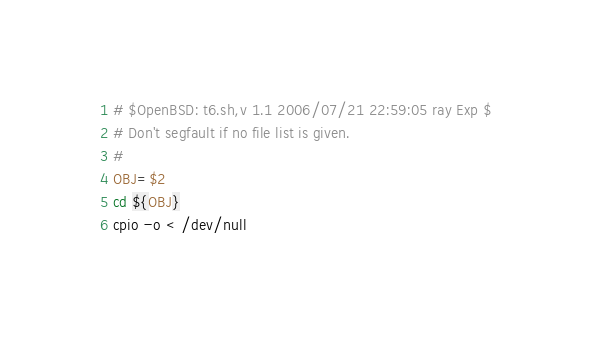<code> <loc_0><loc_0><loc_500><loc_500><_Bash_># $OpenBSD: t6.sh,v 1.1 2006/07/21 22:59:05 ray Exp $
# Don't segfault if no file list is given.
#
OBJ=$2
cd ${OBJ}
cpio -o < /dev/null
</code> 